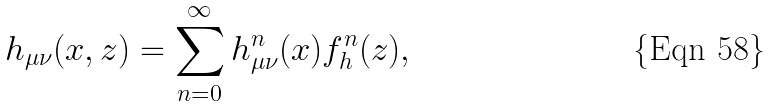<formula> <loc_0><loc_0><loc_500><loc_500>h _ { \mu \nu } ( x , z ) = \sum _ { n = 0 } ^ { \infty } h ^ { n } _ { \mu \nu } ( x ) f _ { h } ^ { n } ( z ) ,</formula> 